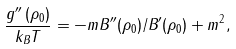<formula> <loc_0><loc_0><loc_500><loc_500>\frac { g ^ { \prime \prime } \left ( \rho _ { 0 } \right ) } { k _ { B } T } = - m B ^ { \prime \prime } ( \rho _ { 0 } ) / B ^ { \prime } ( \rho _ { 0 } ) + m ^ { 2 } ,</formula> 